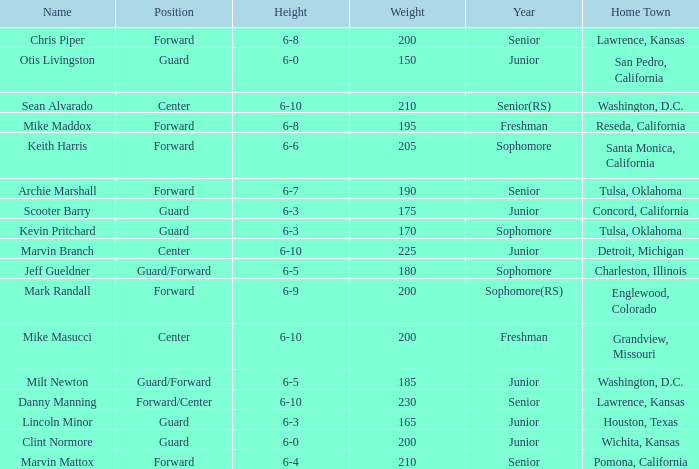Can you tell me the Name that has the Height of 6-5, and the Year of junior? Milt Newton. Could you parse the entire table? {'header': ['Name', 'Position', 'Height', 'Weight', 'Year', 'Home Town'], 'rows': [['Chris Piper', 'Forward', '6-8', '200', 'Senior', 'Lawrence, Kansas'], ['Otis Livingston', 'Guard', '6-0', '150', 'Junior', 'San Pedro, California'], ['Sean Alvarado', 'Center', '6-10', '210', 'Senior(RS)', 'Washington, D.C.'], ['Mike Maddox', 'Forward', '6-8', '195', 'Freshman', 'Reseda, California'], ['Keith Harris', 'Forward', '6-6', '205', 'Sophomore', 'Santa Monica, California'], ['Archie Marshall', 'Forward', '6-7', '190', 'Senior', 'Tulsa, Oklahoma'], ['Scooter Barry', 'Guard', '6-3', '175', 'Junior', 'Concord, California'], ['Kevin Pritchard', 'Guard', '6-3', '170', 'Sophomore', 'Tulsa, Oklahoma'], ['Marvin Branch', 'Center', '6-10', '225', 'Junior', 'Detroit, Michigan'], ['Jeff Gueldner', 'Guard/Forward', '6-5', '180', 'Sophomore', 'Charleston, Illinois'], ['Mark Randall', 'Forward', '6-9', '200', 'Sophomore(RS)', 'Englewood, Colorado'], ['Mike Masucci', 'Center', '6-10', '200', 'Freshman', 'Grandview, Missouri'], ['Milt Newton', 'Guard/Forward', '6-5', '185', 'Junior', 'Washington, D.C.'], ['Danny Manning', 'Forward/Center', '6-10', '230', 'Senior', 'Lawrence, Kansas'], ['Lincoln Minor', 'Guard', '6-3', '165', 'Junior', 'Houston, Texas'], ['Clint Normore', 'Guard', '6-0', '200', 'Junior', 'Wichita, Kansas'], ['Marvin Mattox', 'Forward', '6-4', '210', 'Senior', 'Pomona, California']]} 